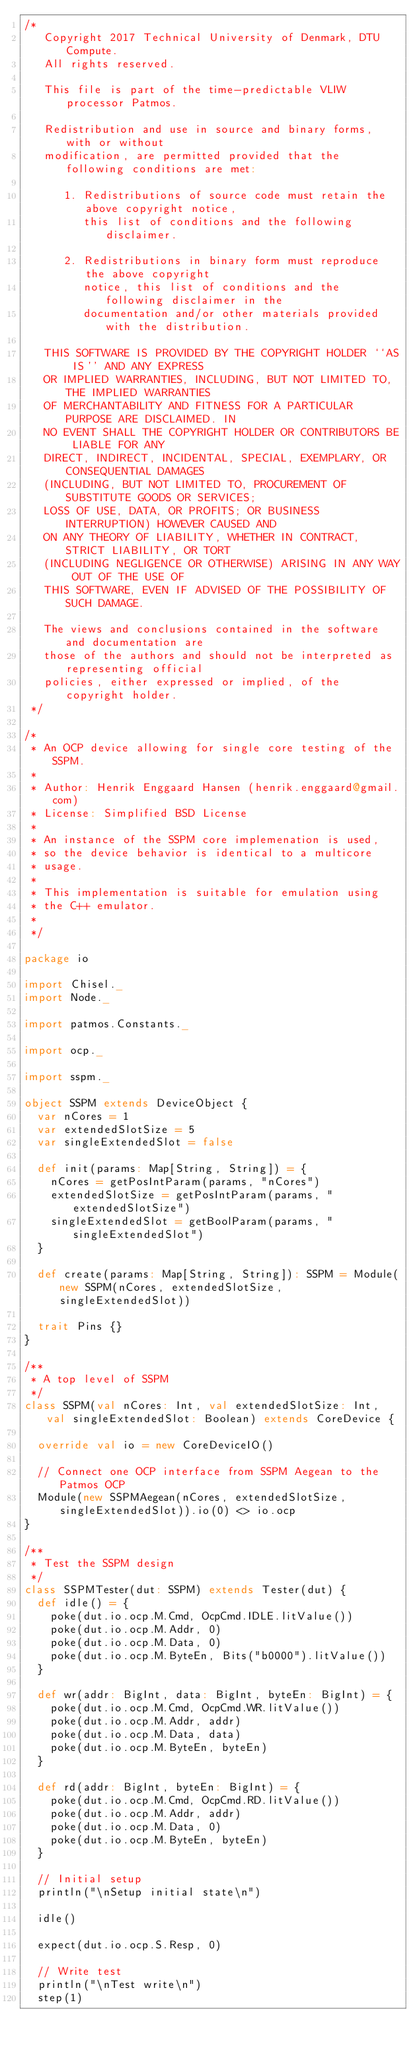<code> <loc_0><loc_0><loc_500><loc_500><_Scala_>/*
   Copyright 2017 Technical University of Denmark, DTU Compute.
   All rights reserved.

   This file is part of the time-predictable VLIW processor Patmos.

   Redistribution and use in source and binary forms, with or without
   modification, are permitted provided that the following conditions are met:

      1. Redistributions of source code must retain the above copyright notice,
         this list of conditions and the following disclaimer.

      2. Redistributions in binary form must reproduce the above copyright
         notice, this list of conditions and the following disclaimer in the
         documentation and/or other materials provided with the distribution.

   THIS SOFTWARE IS PROVIDED BY THE COPYRIGHT HOLDER ``AS IS'' AND ANY EXPRESS
   OR IMPLIED WARRANTIES, INCLUDING, BUT NOT LIMITED TO, THE IMPLIED WARRANTIES
   OF MERCHANTABILITY AND FITNESS FOR A PARTICULAR PURPOSE ARE DISCLAIMED. IN
   NO EVENT SHALL THE COPYRIGHT HOLDER OR CONTRIBUTORS BE LIABLE FOR ANY
   DIRECT, INDIRECT, INCIDENTAL, SPECIAL, EXEMPLARY, OR CONSEQUENTIAL DAMAGES
   (INCLUDING, BUT NOT LIMITED TO, PROCUREMENT OF SUBSTITUTE GOODS OR SERVICES;
   LOSS OF USE, DATA, OR PROFITS; OR BUSINESS INTERRUPTION) HOWEVER CAUSED AND
   ON ANY THEORY OF LIABILITY, WHETHER IN CONTRACT, STRICT LIABILITY, OR TORT
   (INCLUDING NEGLIGENCE OR OTHERWISE) ARISING IN ANY WAY OUT OF THE USE OF
   THIS SOFTWARE, EVEN IF ADVISED OF THE POSSIBILITY OF SUCH DAMAGE.

   The views and conclusions contained in the software and documentation are
   those of the authors and should not be interpreted as representing official
   policies, either expressed or implied, of the copyright holder.
 */

/*
 * An OCP device allowing for single core testing of the SSPM.
 *
 * Author: Henrik Enggaard Hansen (henrik.enggaard@gmail.com)
 * License: Simplified BSD License
 *
 * An instance of the SSPM core implemenation is used,
 * so the device behavior is identical to a multicore
 * usage.
 *
 * This implementation is suitable for emulation using
 * the C++ emulator.
 *
 */

package io

import Chisel._
import Node._

import patmos.Constants._

import ocp._

import sspm._

object SSPM extends DeviceObject {
  var nCores = 1
  var extendedSlotSize = 5
  var singleExtendedSlot = false

  def init(params: Map[String, String]) = {
    nCores = getPosIntParam(params, "nCores")
    extendedSlotSize = getPosIntParam(params, "extendedSlotSize")
    singleExtendedSlot = getBoolParam(params, "singleExtendedSlot")
  }

  def create(params: Map[String, String]): SSPM = Module(new SSPM(nCores, extendedSlotSize, singleExtendedSlot))

  trait Pins {}
}

/**
 * A top level of SSPM
 */
class SSPM(val nCores: Int, val extendedSlotSize: Int, val singleExtendedSlot: Boolean) extends CoreDevice {

  override val io = new CoreDeviceIO()

  // Connect one OCP interface from SSPM Aegean to the Patmos OCP
  Module(new SSPMAegean(nCores, extendedSlotSize, singleExtendedSlot)).io(0) <> io.ocp
}

/**
 * Test the SSPM design
 */
class SSPMTester(dut: SSPM) extends Tester(dut) {
  def idle() = {
    poke(dut.io.ocp.M.Cmd, OcpCmd.IDLE.litValue())
    poke(dut.io.ocp.M.Addr, 0)
    poke(dut.io.ocp.M.Data, 0)
    poke(dut.io.ocp.M.ByteEn, Bits("b0000").litValue())
  }

  def wr(addr: BigInt, data: BigInt, byteEn: BigInt) = {
    poke(dut.io.ocp.M.Cmd, OcpCmd.WR.litValue())
    poke(dut.io.ocp.M.Addr, addr)
    poke(dut.io.ocp.M.Data, data)
    poke(dut.io.ocp.M.ByteEn, byteEn)
  }

  def rd(addr: BigInt, byteEn: BigInt) = {
    poke(dut.io.ocp.M.Cmd, OcpCmd.RD.litValue())
    poke(dut.io.ocp.M.Addr, addr)
    poke(dut.io.ocp.M.Data, 0)
    poke(dut.io.ocp.M.ByteEn, byteEn)
  }

  // Initial setup
  println("\nSetup initial state\n")

  idle()

  expect(dut.io.ocp.S.Resp, 0)

  // Write test
  println("\nTest write\n")
  step(1)
</code> 